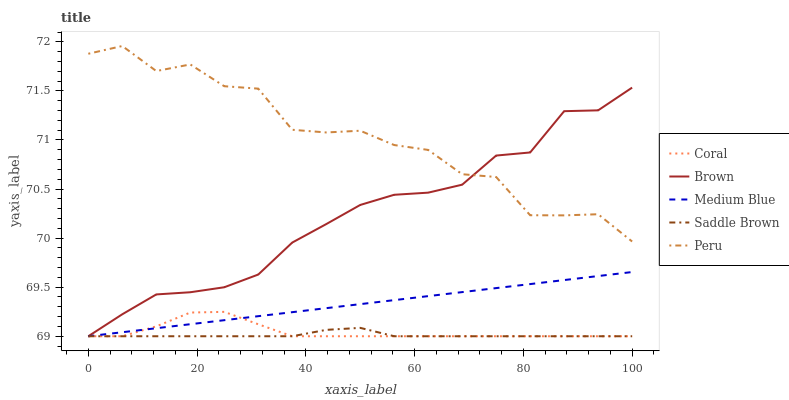Does Saddle Brown have the minimum area under the curve?
Answer yes or no. Yes. Does Peru have the maximum area under the curve?
Answer yes or no. Yes. Does Coral have the minimum area under the curve?
Answer yes or no. No. Does Coral have the maximum area under the curve?
Answer yes or no. No. Is Medium Blue the smoothest?
Answer yes or no. Yes. Is Peru the roughest?
Answer yes or no. Yes. Is Coral the smoothest?
Answer yes or no. No. Is Coral the roughest?
Answer yes or no. No. Does Brown have the lowest value?
Answer yes or no. Yes. Does Peru have the lowest value?
Answer yes or no. No. Does Peru have the highest value?
Answer yes or no. Yes. Does Coral have the highest value?
Answer yes or no. No. Is Saddle Brown less than Peru?
Answer yes or no. Yes. Is Peru greater than Saddle Brown?
Answer yes or no. Yes. Does Saddle Brown intersect Brown?
Answer yes or no. Yes. Is Saddle Brown less than Brown?
Answer yes or no. No. Is Saddle Brown greater than Brown?
Answer yes or no. No. Does Saddle Brown intersect Peru?
Answer yes or no. No. 